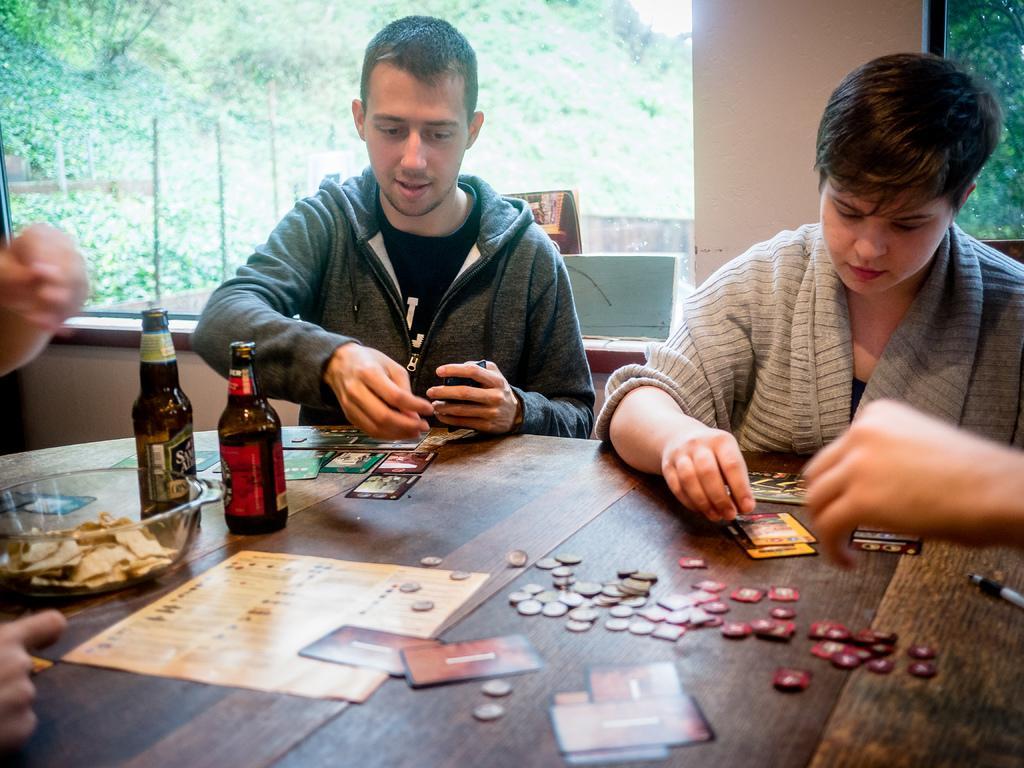Describe this image in one or two sentences. there are two persons sitting on the chair with a table in front of them on the table there are different items through the window we can see nature. 